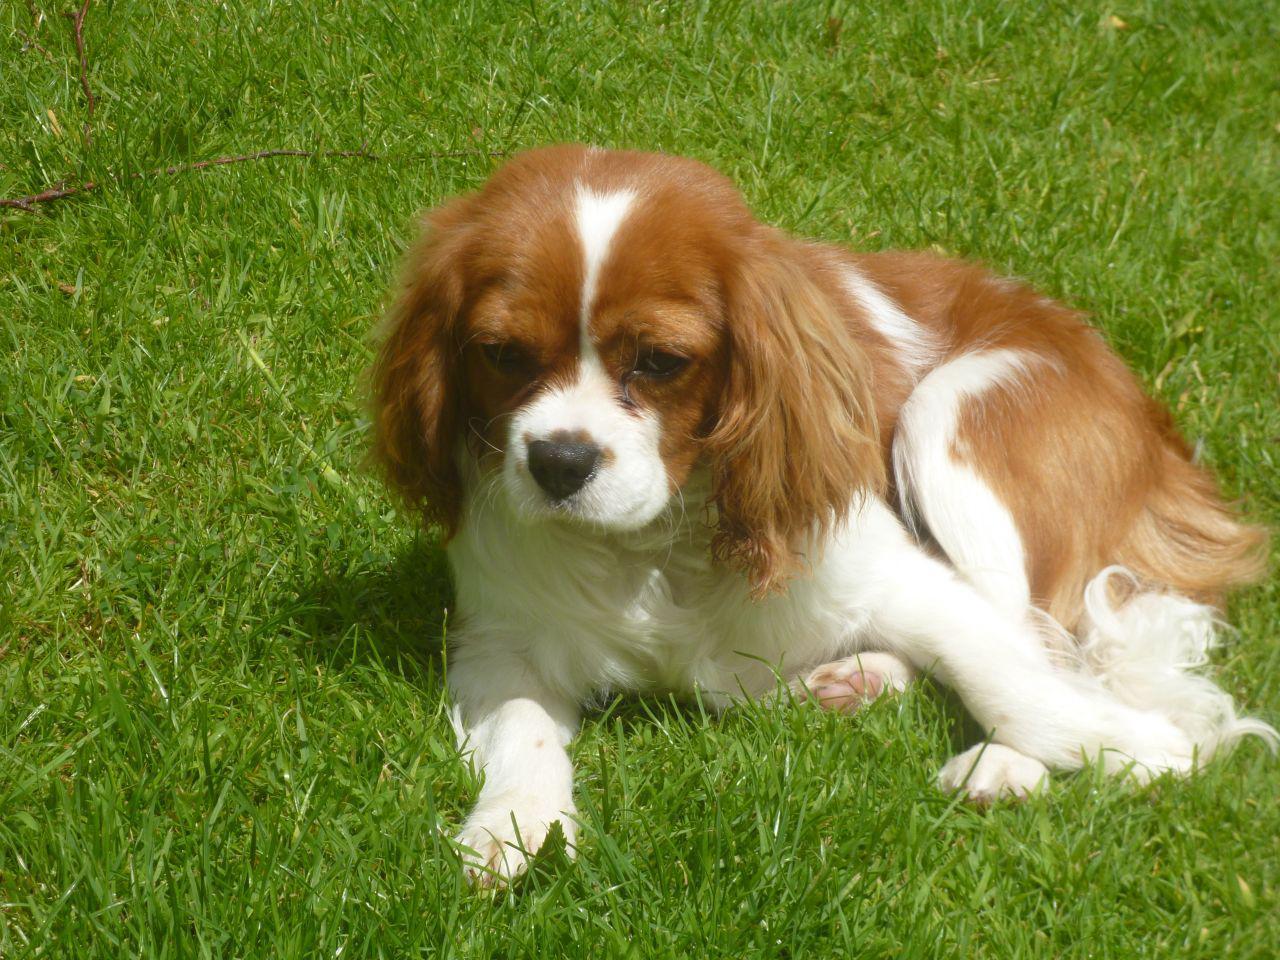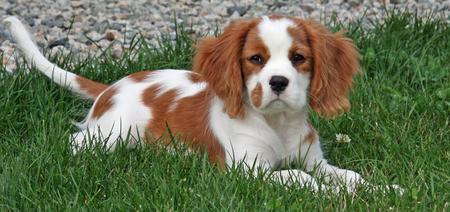The first image is the image on the left, the second image is the image on the right. Examine the images to the left and right. Is the description "Each image shows an orange-and-white spaniel on green grass, and the left image shows a dog sitting upright with body angled leftward." accurate? Answer yes or no. No. 